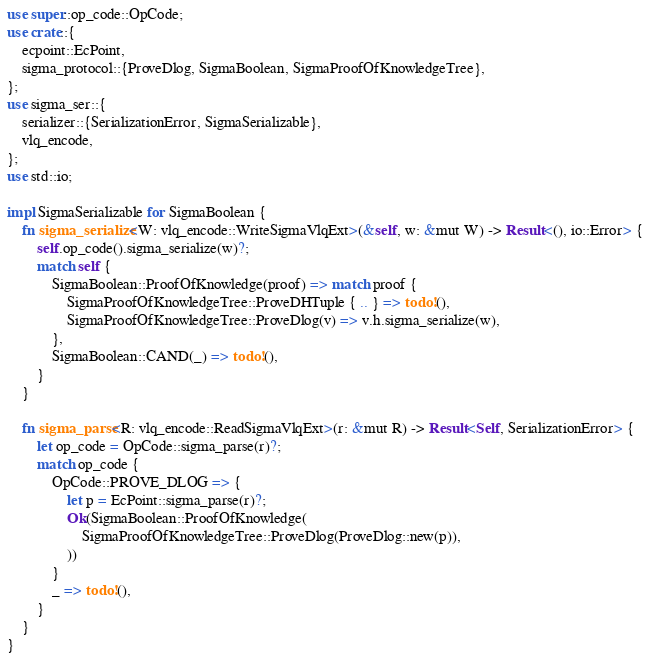<code> <loc_0><loc_0><loc_500><loc_500><_Rust_>use super::op_code::OpCode;
use crate::{
    ecpoint::EcPoint,
    sigma_protocol::{ProveDlog, SigmaBoolean, SigmaProofOfKnowledgeTree},
};
use sigma_ser::{
    serializer::{SerializationError, SigmaSerializable},
    vlq_encode,
};
use std::io;

impl SigmaSerializable for SigmaBoolean {
    fn sigma_serialize<W: vlq_encode::WriteSigmaVlqExt>(&self, w: &mut W) -> Result<(), io::Error> {
        self.op_code().sigma_serialize(w)?;
        match self {
            SigmaBoolean::ProofOfKnowledge(proof) => match proof {
                SigmaProofOfKnowledgeTree::ProveDHTuple { .. } => todo!(),
                SigmaProofOfKnowledgeTree::ProveDlog(v) => v.h.sigma_serialize(w),
            },
            SigmaBoolean::CAND(_) => todo!(),
        }
    }

    fn sigma_parse<R: vlq_encode::ReadSigmaVlqExt>(r: &mut R) -> Result<Self, SerializationError> {
        let op_code = OpCode::sigma_parse(r)?;
        match op_code {
            OpCode::PROVE_DLOG => {
                let p = EcPoint::sigma_parse(r)?;
                Ok(SigmaBoolean::ProofOfKnowledge(
                    SigmaProofOfKnowledgeTree::ProveDlog(ProveDlog::new(p)),
                ))
            }
            _ => todo!(),
        }
    }
}
</code> 